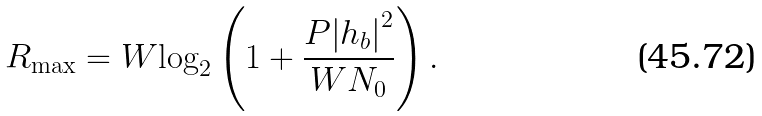<formula> <loc_0><loc_0><loc_500><loc_500>{ R _ { \max } } = W { \log _ { 2 } } \left ( { 1 + \frac { { P { { \left | { h _ { b } } \right | } ^ { 2 } } } } { { W { N _ { 0 } } } } } \right ) .</formula> 